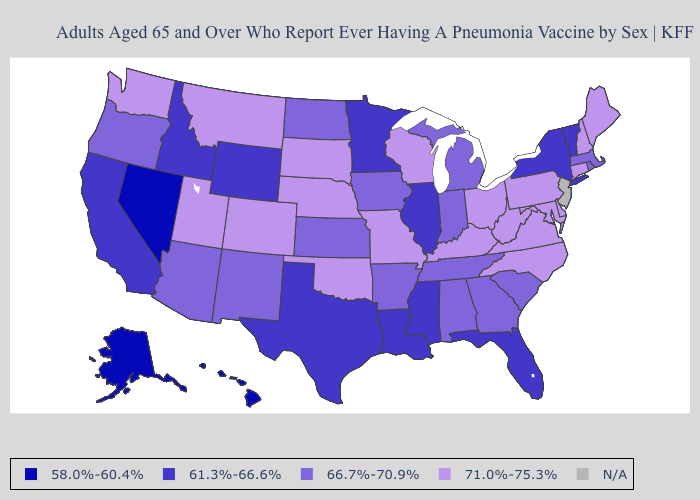Among the states that border Washington , which have the highest value?
Answer briefly. Oregon. Name the states that have a value in the range 66.7%-70.9%?
Concise answer only. Alabama, Arizona, Arkansas, Georgia, Indiana, Iowa, Kansas, Massachusetts, Michigan, New Mexico, North Dakota, Oregon, Rhode Island, South Carolina, Tennessee. What is the value of Colorado?
Short answer required. 71.0%-75.3%. Among the states that border New York , does Pennsylvania have the highest value?
Short answer required. Yes. What is the lowest value in the West?
Short answer required. 58.0%-60.4%. Among the states that border New Jersey , does Delaware have the lowest value?
Write a very short answer. No. What is the highest value in states that border South Carolina?
Keep it brief. 71.0%-75.3%. Name the states that have a value in the range N/A?
Give a very brief answer. New Jersey. What is the value of South Dakota?
Concise answer only. 71.0%-75.3%. What is the value of Connecticut?
Be succinct. 71.0%-75.3%. Among the states that border New Hampshire , which have the highest value?
Answer briefly. Maine. What is the value of North Dakota?
Write a very short answer. 66.7%-70.9%. Among the states that border Kentucky , which have the lowest value?
Answer briefly. Illinois. What is the highest value in states that border Nebraska?
Be succinct. 71.0%-75.3%. 